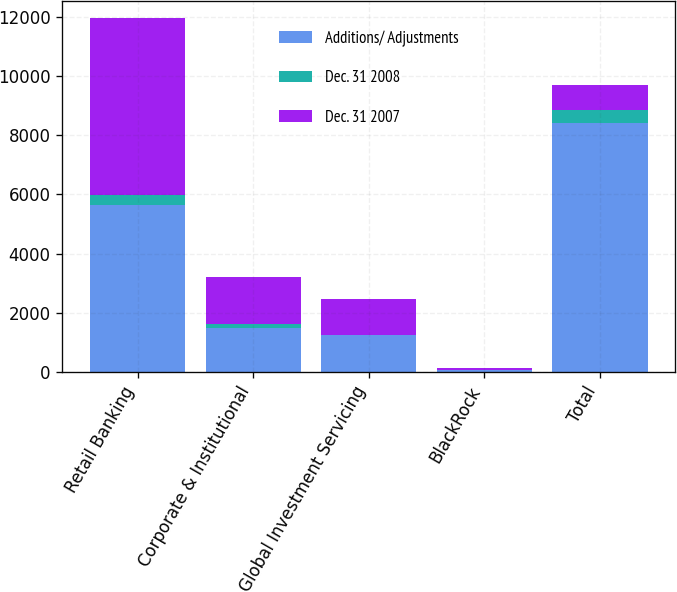Convert chart. <chart><loc_0><loc_0><loc_500><loc_500><stacked_bar_chart><ecel><fcel>Retail Banking<fcel>Corporate & Institutional<fcel>Global Investment Servicing<fcel>BlackRock<fcel>Total<nl><fcel>Additions/ Adjustments<fcel>5628<fcel>1491<fcel>1229<fcel>57<fcel>8405<nl><fcel>Dec. 31 2008<fcel>354<fcel>118<fcel>4<fcel>13<fcel>463<nl><fcel>Dec. 31 2007<fcel>5982<fcel>1609<fcel>1233<fcel>44<fcel>846<nl></chart> 